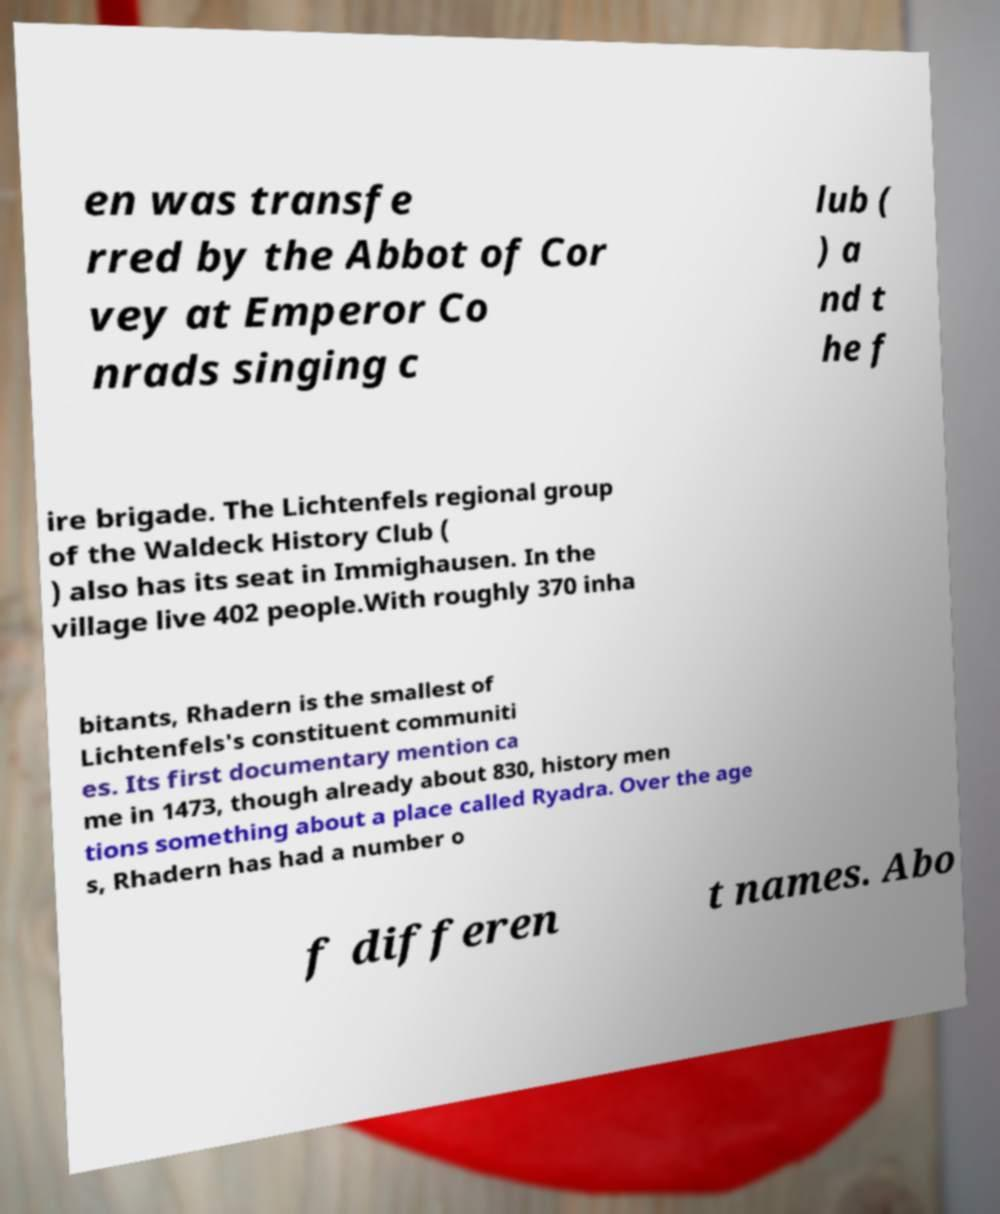I need the written content from this picture converted into text. Can you do that? en was transfe rred by the Abbot of Cor vey at Emperor Co nrads singing c lub ( ) a nd t he f ire brigade. The Lichtenfels regional group of the Waldeck History Club ( ) also has its seat in Immighausen. In the village live 402 people.With roughly 370 inha bitants, Rhadern is the smallest of Lichtenfels's constituent communiti es. Its first documentary mention ca me in 1473, though already about 830, history men tions something about a place called Ryadra. Over the age s, Rhadern has had a number o f differen t names. Abo 